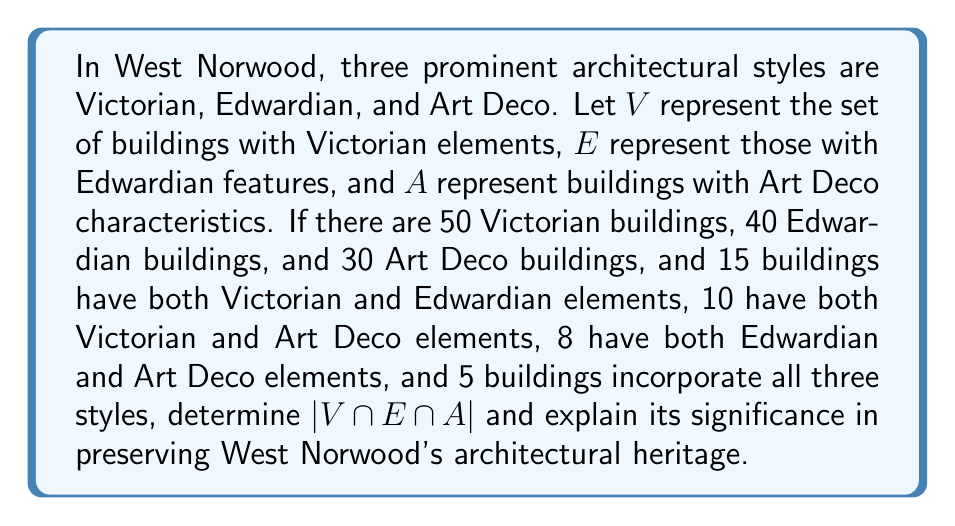Can you answer this question? To solve this problem, we'll use the principle of inclusion-exclusion for three sets. Let's break it down step-by-step:

1) We're given:
   $|V| = 50$, $|E| = 40$, $|A| = 30$
   $|V \cap E| = 15$, $|V \cap A| = 10$, $|E \cap A| = 8$
   $|V \cap E \cap A| = 5$

2) The principle of inclusion-exclusion for three sets states:

   $$|V \cup E \cup A| = |V| + |E| + |A| - |V \cap E| - |V \cap A| - |E \cap A| + |V \cap E \cap A|$$

3) We already know $|V \cap E \cap A| = 5$, which is the answer to the question. However, let's verify this using the given information.

4) Substituting the known values:

   $$|V \cup E \cup A| = 50 + 40 + 30 - 15 - 10 - 8 + 5 = 92$$

5) This means there are 92 unique buildings in West Norwood that have elements of at least one of these architectural styles.

The significance of $|V \cap E \cap A| = 5$ in preserving West Norwood's architectural heritage:

- These 5 buildings represent a unique blend of Victorian, Edwardian, and Art Deco styles, showcasing the neighborhood's rich architectural history.
- They serve as physical timeline markers, illustrating the evolution of architectural tastes and techniques over different periods.
- These buildings are likely to be of particular interest to preservationists and historians due to their unique combination of styles.
- They contribute to the diverse aesthetic appeal of West Norwood, making the area visually interesting and historically significant.
- Identifying these buildings can help in prioritizing conservation efforts, ensuring that these rare examples of multi-period architecture are protected for future generations.
Answer: $|V \cap E \cap A| = 5$ 